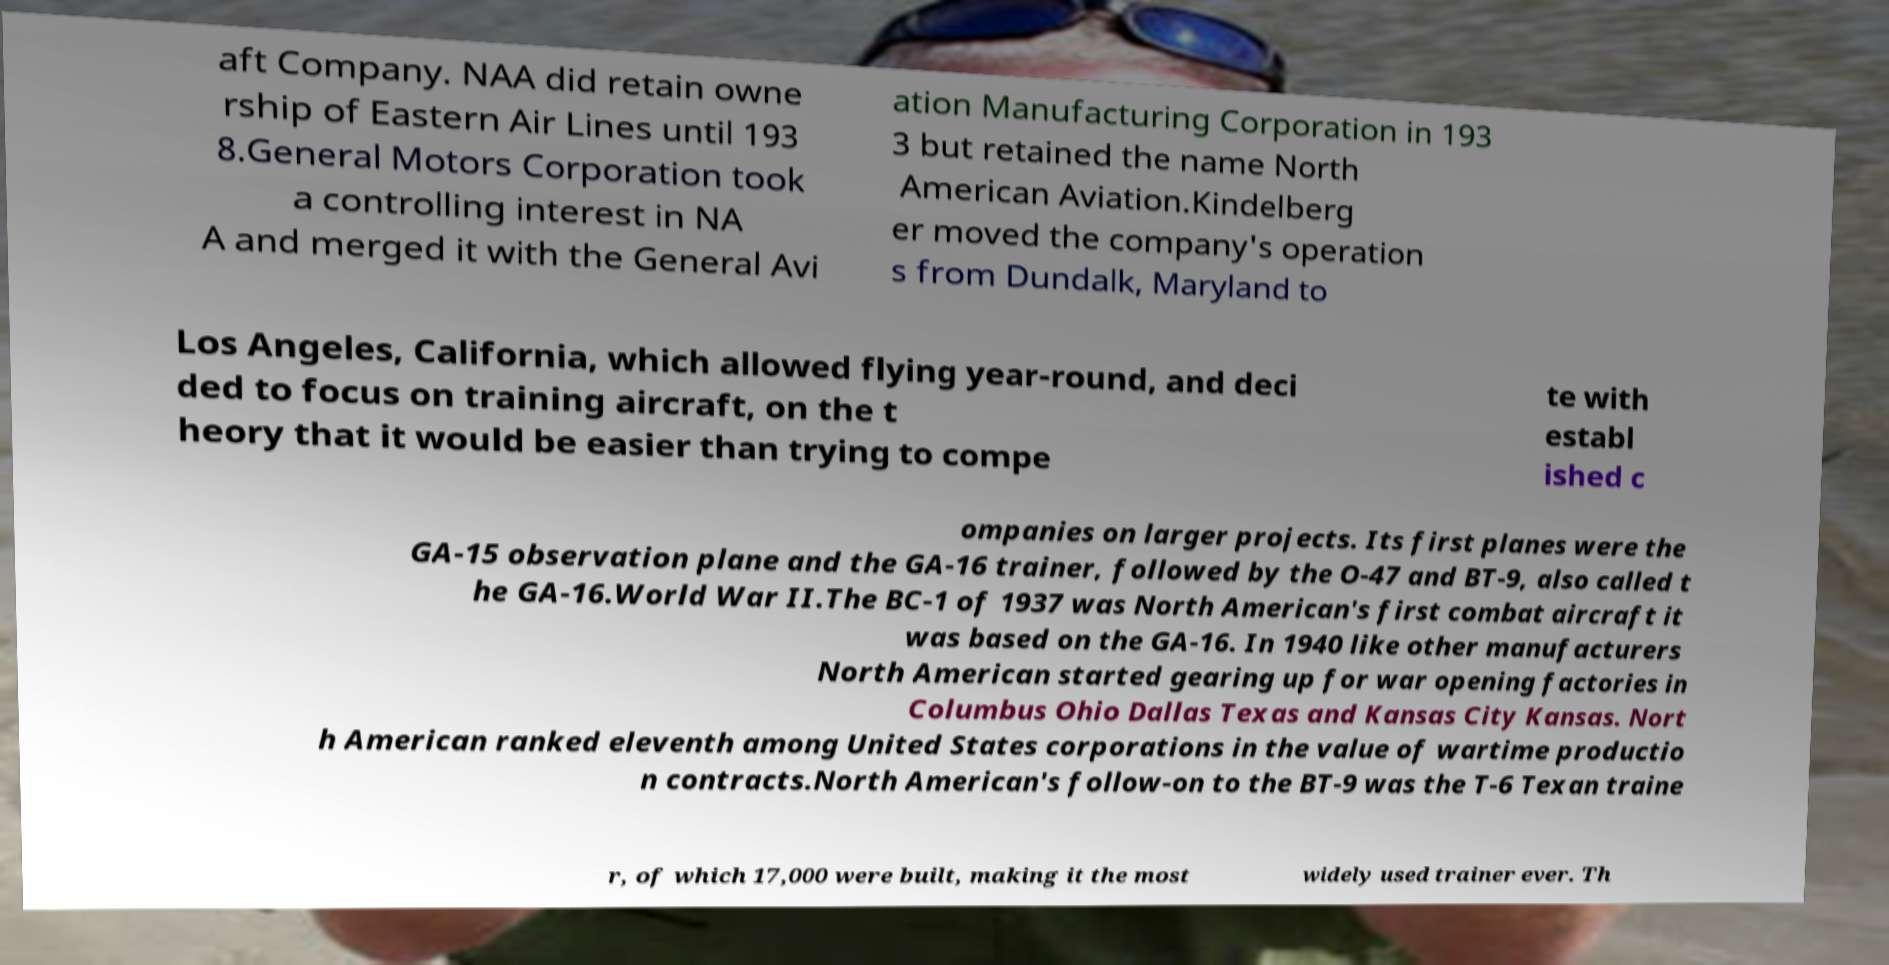Could you assist in decoding the text presented in this image and type it out clearly? aft Company. NAA did retain owne rship of Eastern Air Lines until 193 8.General Motors Corporation took a controlling interest in NA A and merged it with the General Avi ation Manufacturing Corporation in 193 3 but retained the name North American Aviation.Kindelberg er moved the company's operation s from Dundalk, Maryland to Los Angeles, California, which allowed flying year-round, and deci ded to focus on training aircraft, on the t heory that it would be easier than trying to compe te with establ ished c ompanies on larger projects. Its first planes were the GA-15 observation plane and the GA-16 trainer, followed by the O-47 and BT-9, also called t he GA-16.World War II.The BC-1 of 1937 was North American's first combat aircraft it was based on the GA-16. In 1940 like other manufacturers North American started gearing up for war opening factories in Columbus Ohio Dallas Texas and Kansas City Kansas. Nort h American ranked eleventh among United States corporations in the value of wartime productio n contracts.North American's follow-on to the BT-9 was the T-6 Texan traine r, of which 17,000 were built, making it the most widely used trainer ever. Th 